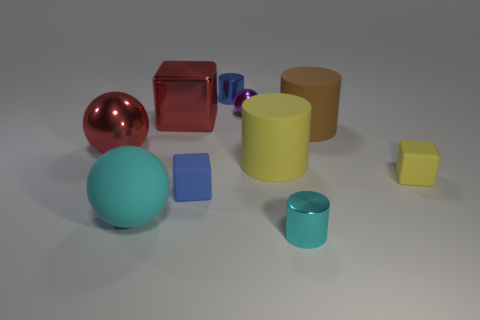What number of other objects are the same size as the cyan matte ball?
Give a very brief answer. 4. There is a object that is the same color as the large metal block; what size is it?
Offer a terse response. Large. How many metallic cylinders have the same color as the large shiny ball?
Your answer should be very brief. 0. What is the shape of the blue metal thing?
Make the answer very short. Cylinder. There is a cylinder that is both behind the big yellow cylinder and on the left side of the cyan metal cylinder; what is its color?
Keep it short and to the point. Blue. What is the brown cylinder made of?
Your answer should be very brief. Rubber. There is a small blue thing that is in front of the big brown rubber cylinder; what is its shape?
Offer a very short reply. Cube. There is another matte block that is the same size as the yellow cube; what is its color?
Offer a very short reply. Blue. Do the yellow object on the left side of the brown rubber object and the blue block have the same material?
Your response must be concise. Yes. What is the size of the metal thing that is in front of the big brown matte cylinder and to the right of the tiny blue rubber thing?
Your answer should be compact. Small. 